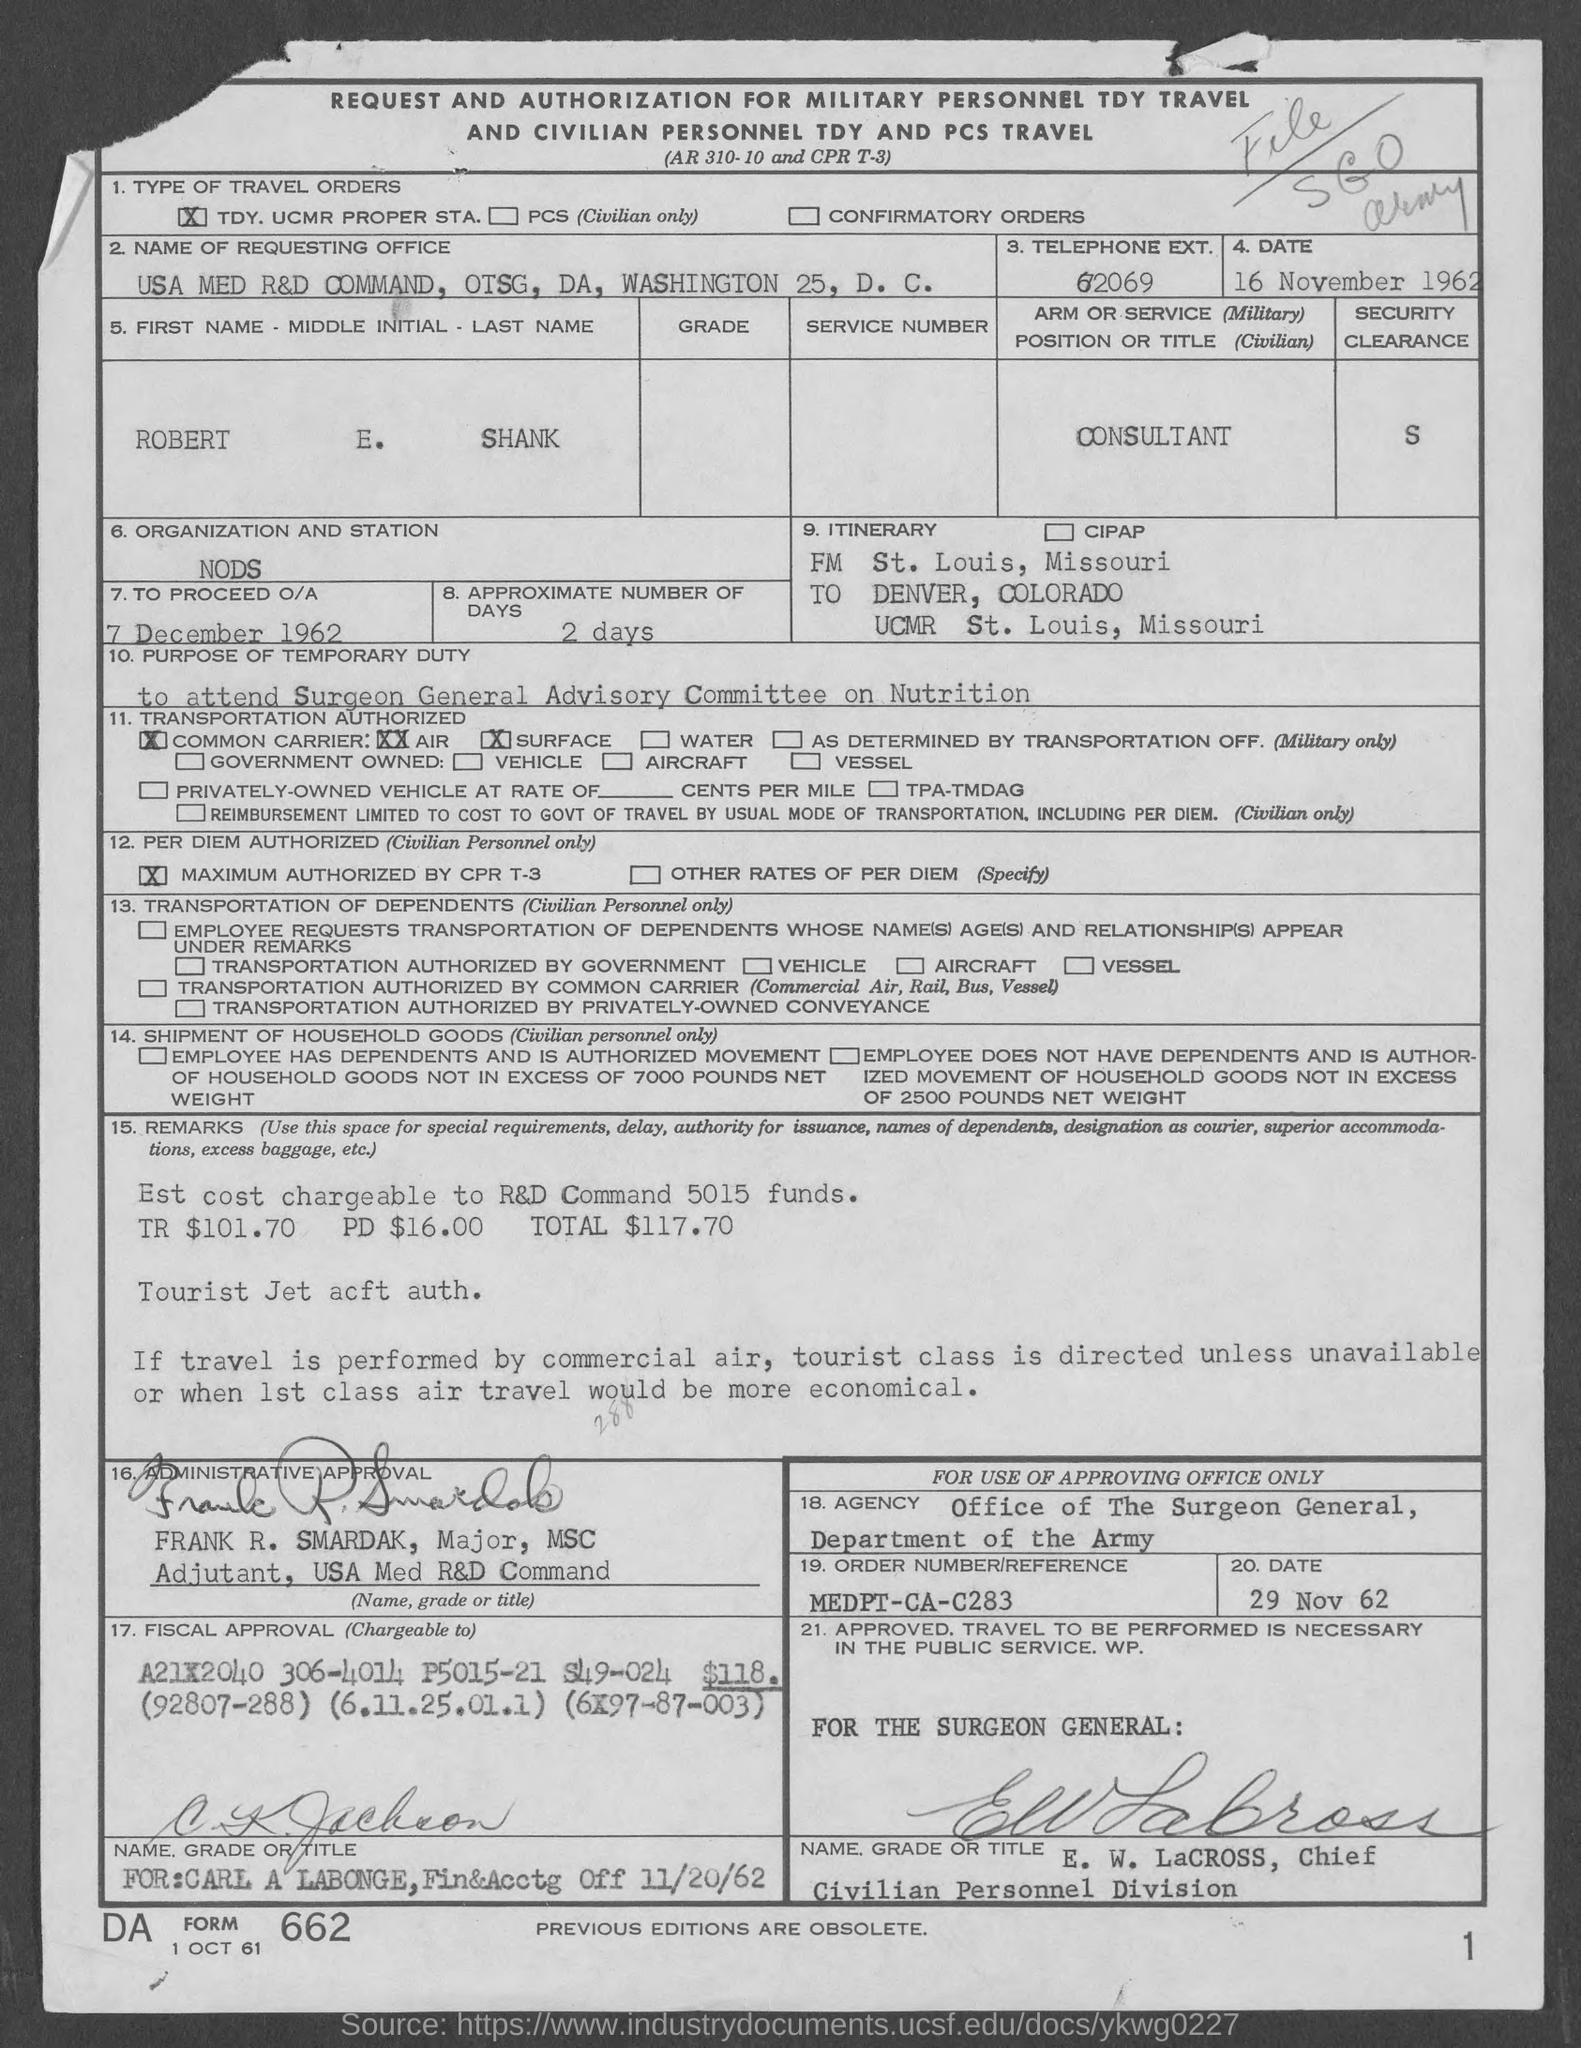What is the telephone ext. given?
Offer a very short reply. 62069. What is the date given?
Provide a succinct answer. 16 November 1962. What is the arm or service position or title?
Keep it short and to the point. Consultant. What is the approximate number of days?
Keep it short and to the point. 2 days. 